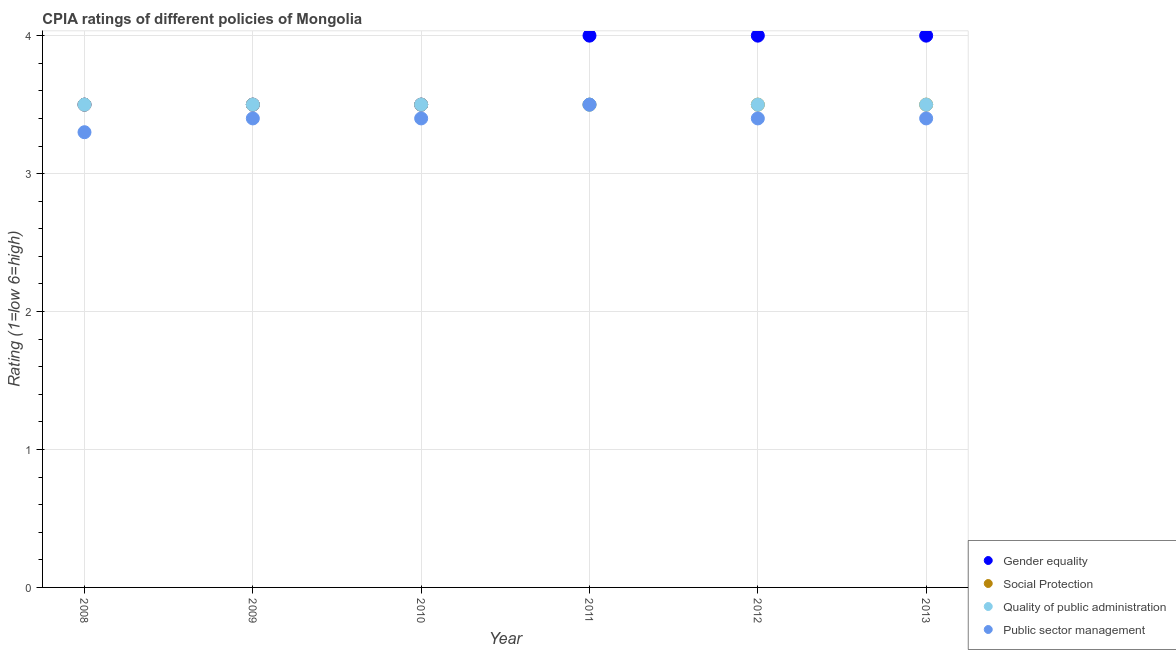How many different coloured dotlines are there?
Your answer should be very brief. 4. Is the number of dotlines equal to the number of legend labels?
Provide a short and direct response. Yes. Across all years, what is the minimum cpia rating of public sector management?
Your response must be concise. 3.3. In which year was the cpia rating of gender equality minimum?
Your answer should be compact. 2008. What is the difference between the cpia rating of quality of public administration in 2012 and the cpia rating of social protection in 2009?
Your response must be concise. 0. What is the average cpia rating of gender equality per year?
Offer a terse response. 3.75. What is the ratio of the cpia rating of public sector management in 2009 to that in 2011?
Your answer should be very brief. 0.97. Is the cpia rating of public sector management in 2010 less than that in 2011?
Provide a succinct answer. Yes. What is the difference between the highest and the second highest cpia rating of public sector management?
Keep it short and to the point. 0.1. What is the difference between the highest and the lowest cpia rating of social protection?
Offer a very short reply. 0. In how many years, is the cpia rating of gender equality greater than the average cpia rating of gender equality taken over all years?
Offer a very short reply. 3. Is the sum of the cpia rating of public sector management in 2009 and 2013 greater than the maximum cpia rating of gender equality across all years?
Provide a short and direct response. Yes. Is it the case that in every year, the sum of the cpia rating of gender equality and cpia rating of social protection is greater than the sum of cpia rating of public sector management and cpia rating of quality of public administration?
Your response must be concise. No. How many years are there in the graph?
Ensure brevity in your answer.  6. What is the difference between two consecutive major ticks on the Y-axis?
Your response must be concise. 1. Does the graph contain any zero values?
Provide a succinct answer. No. Does the graph contain grids?
Offer a very short reply. Yes. Where does the legend appear in the graph?
Offer a terse response. Bottom right. How many legend labels are there?
Provide a short and direct response. 4. How are the legend labels stacked?
Your answer should be very brief. Vertical. What is the title of the graph?
Give a very brief answer. CPIA ratings of different policies of Mongolia. What is the label or title of the X-axis?
Make the answer very short. Year. What is the label or title of the Y-axis?
Offer a very short reply. Rating (1=low 6=high). What is the Rating (1=low 6=high) in Gender equality in 2008?
Provide a succinct answer. 3.5. What is the Rating (1=low 6=high) of Quality of public administration in 2008?
Provide a short and direct response. 3.5. What is the Rating (1=low 6=high) of Public sector management in 2008?
Your response must be concise. 3.3. What is the Rating (1=low 6=high) of Gender equality in 2009?
Keep it short and to the point. 3.5. What is the Rating (1=low 6=high) in Social Protection in 2009?
Your answer should be very brief. 3.5. What is the Rating (1=low 6=high) of Gender equality in 2010?
Your answer should be very brief. 3.5. What is the Rating (1=low 6=high) in Gender equality in 2011?
Ensure brevity in your answer.  4. What is the Rating (1=low 6=high) in Quality of public administration in 2011?
Make the answer very short. 3.5. What is the Rating (1=low 6=high) of Social Protection in 2012?
Make the answer very short. 3.5. What is the Rating (1=low 6=high) of Public sector management in 2012?
Give a very brief answer. 3.4. What is the Rating (1=low 6=high) in Gender equality in 2013?
Offer a terse response. 4. What is the Rating (1=low 6=high) in Public sector management in 2013?
Keep it short and to the point. 3.4. Across all years, what is the maximum Rating (1=low 6=high) in Gender equality?
Your answer should be very brief. 4. Across all years, what is the maximum Rating (1=low 6=high) of Social Protection?
Give a very brief answer. 3.5. Across all years, what is the minimum Rating (1=low 6=high) of Gender equality?
Offer a terse response. 3.5. Across all years, what is the minimum Rating (1=low 6=high) of Social Protection?
Ensure brevity in your answer.  3.5. What is the total Rating (1=low 6=high) of Gender equality in the graph?
Your answer should be very brief. 22.5. What is the total Rating (1=low 6=high) in Public sector management in the graph?
Your response must be concise. 20.4. What is the difference between the Rating (1=low 6=high) in Gender equality in 2008 and that in 2009?
Provide a short and direct response. 0. What is the difference between the Rating (1=low 6=high) in Social Protection in 2008 and that in 2009?
Your answer should be compact. 0. What is the difference between the Rating (1=low 6=high) in Public sector management in 2008 and that in 2009?
Keep it short and to the point. -0.1. What is the difference between the Rating (1=low 6=high) in Gender equality in 2008 and that in 2010?
Your answer should be very brief. 0. What is the difference between the Rating (1=low 6=high) in Social Protection in 2008 and that in 2010?
Offer a very short reply. 0. What is the difference between the Rating (1=low 6=high) in Public sector management in 2008 and that in 2010?
Keep it short and to the point. -0.1. What is the difference between the Rating (1=low 6=high) of Gender equality in 2008 and that in 2011?
Ensure brevity in your answer.  -0.5. What is the difference between the Rating (1=low 6=high) of Social Protection in 2008 and that in 2011?
Keep it short and to the point. 0. What is the difference between the Rating (1=low 6=high) of Quality of public administration in 2008 and that in 2011?
Your answer should be very brief. 0. What is the difference between the Rating (1=low 6=high) in Public sector management in 2008 and that in 2011?
Keep it short and to the point. -0.2. What is the difference between the Rating (1=low 6=high) of Gender equality in 2008 and that in 2012?
Keep it short and to the point. -0.5. What is the difference between the Rating (1=low 6=high) of Social Protection in 2008 and that in 2012?
Your answer should be very brief. 0. What is the difference between the Rating (1=low 6=high) of Quality of public administration in 2008 and that in 2012?
Provide a succinct answer. 0. What is the difference between the Rating (1=low 6=high) in Quality of public administration in 2008 and that in 2013?
Your answer should be very brief. 0. What is the difference between the Rating (1=low 6=high) in Public sector management in 2008 and that in 2013?
Give a very brief answer. -0.1. What is the difference between the Rating (1=low 6=high) in Public sector management in 2009 and that in 2010?
Offer a terse response. 0. What is the difference between the Rating (1=low 6=high) in Social Protection in 2009 and that in 2011?
Provide a short and direct response. 0. What is the difference between the Rating (1=low 6=high) in Gender equality in 2009 and that in 2012?
Make the answer very short. -0.5. What is the difference between the Rating (1=low 6=high) in Quality of public administration in 2009 and that in 2012?
Ensure brevity in your answer.  0. What is the difference between the Rating (1=low 6=high) of Public sector management in 2009 and that in 2012?
Your response must be concise. 0. What is the difference between the Rating (1=low 6=high) in Gender equality in 2009 and that in 2013?
Your answer should be very brief. -0.5. What is the difference between the Rating (1=low 6=high) in Quality of public administration in 2009 and that in 2013?
Offer a terse response. 0. What is the difference between the Rating (1=low 6=high) in Public sector management in 2009 and that in 2013?
Your answer should be compact. 0. What is the difference between the Rating (1=low 6=high) of Gender equality in 2010 and that in 2011?
Offer a terse response. -0.5. What is the difference between the Rating (1=low 6=high) of Social Protection in 2010 and that in 2011?
Ensure brevity in your answer.  0. What is the difference between the Rating (1=low 6=high) in Gender equality in 2010 and that in 2012?
Offer a terse response. -0.5. What is the difference between the Rating (1=low 6=high) of Public sector management in 2010 and that in 2012?
Offer a terse response. 0. What is the difference between the Rating (1=low 6=high) in Social Protection in 2010 and that in 2013?
Offer a terse response. 0. What is the difference between the Rating (1=low 6=high) of Quality of public administration in 2010 and that in 2013?
Your answer should be very brief. 0. What is the difference between the Rating (1=low 6=high) in Public sector management in 2010 and that in 2013?
Offer a very short reply. 0. What is the difference between the Rating (1=low 6=high) in Social Protection in 2011 and that in 2012?
Your answer should be very brief. 0. What is the difference between the Rating (1=low 6=high) of Quality of public administration in 2011 and that in 2012?
Provide a short and direct response. 0. What is the difference between the Rating (1=low 6=high) in Public sector management in 2011 and that in 2013?
Provide a succinct answer. 0.1. What is the difference between the Rating (1=low 6=high) of Social Protection in 2012 and that in 2013?
Provide a succinct answer. 0. What is the difference between the Rating (1=low 6=high) of Public sector management in 2012 and that in 2013?
Provide a succinct answer. 0. What is the difference between the Rating (1=low 6=high) of Gender equality in 2008 and the Rating (1=low 6=high) of Social Protection in 2009?
Your answer should be compact. 0. What is the difference between the Rating (1=low 6=high) of Gender equality in 2008 and the Rating (1=low 6=high) of Quality of public administration in 2009?
Keep it short and to the point. 0. What is the difference between the Rating (1=low 6=high) in Social Protection in 2008 and the Rating (1=low 6=high) in Quality of public administration in 2009?
Your response must be concise. 0. What is the difference between the Rating (1=low 6=high) in Social Protection in 2008 and the Rating (1=low 6=high) in Public sector management in 2009?
Your answer should be compact. 0.1. What is the difference between the Rating (1=low 6=high) of Gender equality in 2008 and the Rating (1=low 6=high) of Social Protection in 2010?
Your response must be concise. 0. What is the difference between the Rating (1=low 6=high) in Social Protection in 2008 and the Rating (1=low 6=high) in Quality of public administration in 2010?
Provide a short and direct response. 0. What is the difference between the Rating (1=low 6=high) of Gender equality in 2008 and the Rating (1=low 6=high) of Social Protection in 2011?
Offer a very short reply. 0. What is the difference between the Rating (1=low 6=high) in Social Protection in 2008 and the Rating (1=low 6=high) in Public sector management in 2011?
Offer a very short reply. 0. What is the difference between the Rating (1=low 6=high) of Quality of public administration in 2008 and the Rating (1=low 6=high) of Public sector management in 2011?
Your answer should be compact. 0. What is the difference between the Rating (1=low 6=high) in Gender equality in 2008 and the Rating (1=low 6=high) in Social Protection in 2012?
Offer a very short reply. 0. What is the difference between the Rating (1=low 6=high) in Gender equality in 2008 and the Rating (1=low 6=high) in Public sector management in 2012?
Your answer should be very brief. 0.1. What is the difference between the Rating (1=low 6=high) of Social Protection in 2008 and the Rating (1=low 6=high) of Quality of public administration in 2012?
Your response must be concise. 0. What is the difference between the Rating (1=low 6=high) of Social Protection in 2008 and the Rating (1=low 6=high) of Public sector management in 2012?
Keep it short and to the point. 0.1. What is the difference between the Rating (1=low 6=high) of Social Protection in 2008 and the Rating (1=low 6=high) of Public sector management in 2013?
Ensure brevity in your answer.  0.1. What is the difference between the Rating (1=low 6=high) of Quality of public administration in 2008 and the Rating (1=low 6=high) of Public sector management in 2013?
Your answer should be compact. 0.1. What is the difference between the Rating (1=low 6=high) of Gender equality in 2009 and the Rating (1=low 6=high) of Social Protection in 2010?
Ensure brevity in your answer.  0. What is the difference between the Rating (1=low 6=high) in Quality of public administration in 2009 and the Rating (1=low 6=high) in Public sector management in 2010?
Offer a very short reply. 0.1. What is the difference between the Rating (1=low 6=high) of Social Protection in 2009 and the Rating (1=low 6=high) of Quality of public administration in 2011?
Ensure brevity in your answer.  0. What is the difference between the Rating (1=low 6=high) in Social Protection in 2009 and the Rating (1=low 6=high) in Public sector management in 2011?
Make the answer very short. 0. What is the difference between the Rating (1=low 6=high) in Quality of public administration in 2009 and the Rating (1=low 6=high) in Public sector management in 2011?
Your answer should be very brief. 0. What is the difference between the Rating (1=low 6=high) of Gender equality in 2009 and the Rating (1=low 6=high) of Quality of public administration in 2013?
Your answer should be very brief. 0. What is the difference between the Rating (1=low 6=high) of Social Protection in 2009 and the Rating (1=low 6=high) of Quality of public administration in 2013?
Make the answer very short. 0. What is the difference between the Rating (1=low 6=high) in Quality of public administration in 2009 and the Rating (1=low 6=high) in Public sector management in 2013?
Keep it short and to the point. 0.1. What is the difference between the Rating (1=low 6=high) of Quality of public administration in 2010 and the Rating (1=low 6=high) of Public sector management in 2011?
Provide a short and direct response. 0. What is the difference between the Rating (1=low 6=high) in Gender equality in 2010 and the Rating (1=low 6=high) in Quality of public administration in 2012?
Make the answer very short. 0. What is the difference between the Rating (1=low 6=high) of Quality of public administration in 2010 and the Rating (1=low 6=high) of Public sector management in 2012?
Make the answer very short. 0.1. What is the difference between the Rating (1=low 6=high) in Gender equality in 2010 and the Rating (1=low 6=high) in Social Protection in 2013?
Offer a very short reply. 0. What is the difference between the Rating (1=low 6=high) in Gender equality in 2010 and the Rating (1=low 6=high) in Quality of public administration in 2013?
Your answer should be compact. 0. What is the difference between the Rating (1=low 6=high) of Social Protection in 2010 and the Rating (1=low 6=high) of Quality of public administration in 2013?
Offer a very short reply. 0. What is the difference between the Rating (1=low 6=high) in Social Protection in 2010 and the Rating (1=low 6=high) in Public sector management in 2013?
Make the answer very short. 0.1. What is the difference between the Rating (1=low 6=high) of Quality of public administration in 2010 and the Rating (1=low 6=high) of Public sector management in 2013?
Make the answer very short. 0.1. What is the difference between the Rating (1=low 6=high) in Gender equality in 2011 and the Rating (1=low 6=high) in Quality of public administration in 2012?
Offer a terse response. 0.5. What is the difference between the Rating (1=low 6=high) in Gender equality in 2011 and the Rating (1=low 6=high) in Public sector management in 2012?
Offer a terse response. 0.6. What is the difference between the Rating (1=low 6=high) in Social Protection in 2011 and the Rating (1=low 6=high) in Public sector management in 2012?
Make the answer very short. 0.1. What is the difference between the Rating (1=low 6=high) of Quality of public administration in 2011 and the Rating (1=low 6=high) of Public sector management in 2012?
Keep it short and to the point. 0.1. What is the difference between the Rating (1=low 6=high) in Gender equality in 2011 and the Rating (1=low 6=high) in Public sector management in 2013?
Provide a short and direct response. 0.6. What is the difference between the Rating (1=low 6=high) in Social Protection in 2011 and the Rating (1=low 6=high) in Public sector management in 2013?
Keep it short and to the point. 0.1. What is the difference between the Rating (1=low 6=high) of Quality of public administration in 2011 and the Rating (1=low 6=high) of Public sector management in 2013?
Your response must be concise. 0.1. What is the difference between the Rating (1=low 6=high) of Social Protection in 2012 and the Rating (1=low 6=high) of Quality of public administration in 2013?
Offer a terse response. 0. What is the difference between the Rating (1=low 6=high) of Quality of public administration in 2012 and the Rating (1=low 6=high) of Public sector management in 2013?
Ensure brevity in your answer.  0.1. What is the average Rating (1=low 6=high) of Gender equality per year?
Give a very brief answer. 3.75. What is the average Rating (1=low 6=high) of Social Protection per year?
Your response must be concise. 3.5. In the year 2008, what is the difference between the Rating (1=low 6=high) of Gender equality and Rating (1=low 6=high) of Public sector management?
Provide a succinct answer. 0.2. In the year 2008, what is the difference between the Rating (1=low 6=high) of Social Protection and Rating (1=low 6=high) of Quality of public administration?
Keep it short and to the point. 0. In the year 2008, what is the difference between the Rating (1=low 6=high) of Quality of public administration and Rating (1=low 6=high) of Public sector management?
Ensure brevity in your answer.  0.2. In the year 2009, what is the difference between the Rating (1=low 6=high) in Gender equality and Rating (1=low 6=high) in Social Protection?
Keep it short and to the point. 0. In the year 2009, what is the difference between the Rating (1=low 6=high) in Gender equality and Rating (1=low 6=high) in Public sector management?
Your answer should be very brief. 0.1. In the year 2009, what is the difference between the Rating (1=low 6=high) in Social Protection and Rating (1=low 6=high) in Quality of public administration?
Your response must be concise. 0. In the year 2009, what is the difference between the Rating (1=low 6=high) in Quality of public administration and Rating (1=low 6=high) in Public sector management?
Ensure brevity in your answer.  0.1. In the year 2010, what is the difference between the Rating (1=low 6=high) of Social Protection and Rating (1=low 6=high) of Quality of public administration?
Your response must be concise. 0. In the year 2011, what is the difference between the Rating (1=low 6=high) of Social Protection and Rating (1=low 6=high) of Public sector management?
Your answer should be very brief. 0. In the year 2011, what is the difference between the Rating (1=low 6=high) in Quality of public administration and Rating (1=low 6=high) in Public sector management?
Your response must be concise. 0. In the year 2012, what is the difference between the Rating (1=low 6=high) of Gender equality and Rating (1=low 6=high) of Public sector management?
Provide a short and direct response. 0.6. In the year 2012, what is the difference between the Rating (1=low 6=high) of Social Protection and Rating (1=low 6=high) of Quality of public administration?
Give a very brief answer. 0. In the year 2012, what is the difference between the Rating (1=low 6=high) in Social Protection and Rating (1=low 6=high) in Public sector management?
Provide a succinct answer. 0.1. In the year 2013, what is the difference between the Rating (1=low 6=high) of Gender equality and Rating (1=low 6=high) of Social Protection?
Offer a very short reply. 0.5. In the year 2013, what is the difference between the Rating (1=low 6=high) of Gender equality and Rating (1=low 6=high) of Quality of public administration?
Provide a short and direct response. 0.5. In the year 2013, what is the difference between the Rating (1=low 6=high) in Social Protection and Rating (1=low 6=high) in Quality of public administration?
Keep it short and to the point. 0. In the year 2013, what is the difference between the Rating (1=low 6=high) of Social Protection and Rating (1=low 6=high) of Public sector management?
Provide a short and direct response. 0.1. In the year 2013, what is the difference between the Rating (1=low 6=high) in Quality of public administration and Rating (1=low 6=high) in Public sector management?
Your response must be concise. 0.1. What is the ratio of the Rating (1=low 6=high) of Quality of public administration in 2008 to that in 2009?
Provide a short and direct response. 1. What is the ratio of the Rating (1=low 6=high) in Public sector management in 2008 to that in 2009?
Offer a very short reply. 0.97. What is the ratio of the Rating (1=low 6=high) in Public sector management in 2008 to that in 2010?
Provide a succinct answer. 0.97. What is the ratio of the Rating (1=low 6=high) of Social Protection in 2008 to that in 2011?
Make the answer very short. 1. What is the ratio of the Rating (1=low 6=high) in Public sector management in 2008 to that in 2011?
Keep it short and to the point. 0.94. What is the ratio of the Rating (1=low 6=high) of Social Protection in 2008 to that in 2012?
Your answer should be very brief. 1. What is the ratio of the Rating (1=low 6=high) in Quality of public administration in 2008 to that in 2012?
Give a very brief answer. 1. What is the ratio of the Rating (1=low 6=high) of Public sector management in 2008 to that in 2012?
Ensure brevity in your answer.  0.97. What is the ratio of the Rating (1=low 6=high) of Gender equality in 2008 to that in 2013?
Your response must be concise. 0.88. What is the ratio of the Rating (1=low 6=high) of Quality of public administration in 2008 to that in 2013?
Give a very brief answer. 1. What is the ratio of the Rating (1=low 6=high) in Public sector management in 2008 to that in 2013?
Your answer should be very brief. 0.97. What is the ratio of the Rating (1=low 6=high) of Social Protection in 2009 to that in 2010?
Make the answer very short. 1. What is the ratio of the Rating (1=low 6=high) in Quality of public administration in 2009 to that in 2010?
Your answer should be compact. 1. What is the ratio of the Rating (1=low 6=high) in Public sector management in 2009 to that in 2010?
Offer a very short reply. 1. What is the ratio of the Rating (1=low 6=high) in Public sector management in 2009 to that in 2011?
Your response must be concise. 0.97. What is the ratio of the Rating (1=low 6=high) of Gender equality in 2009 to that in 2012?
Provide a succinct answer. 0.88. What is the ratio of the Rating (1=low 6=high) of Social Protection in 2009 to that in 2012?
Give a very brief answer. 1. What is the ratio of the Rating (1=low 6=high) of Quality of public administration in 2009 to that in 2012?
Provide a succinct answer. 1. What is the ratio of the Rating (1=low 6=high) of Social Protection in 2009 to that in 2013?
Provide a short and direct response. 1. What is the ratio of the Rating (1=low 6=high) in Public sector management in 2009 to that in 2013?
Keep it short and to the point. 1. What is the ratio of the Rating (1=low 6=high) of Gender equality in 2010 to that in 2011?
Provide a succinct answer. 0.88. What is the ratio of the Rating (1=low 6=high) in Quality of public administration in 2010 to that in 2011?
Provide a succinct answer. 1. What is the ratio of the Rating (1=low 6=high) of Public sector management in 2010 to that in 2011?
Your answer should be very brief. 0.97. What is the ratio of the Rating (1=low 6=high) in Gender equality in 2010 to that in 2012?
Make the answer very short. 0.88. What is the ratio of the Rating (1=low 6=high) in Public sector management in 2010 to that in 2012?
Your response must be concise. 1. What is the ratio of the Rating (1=low 6=high) of Gender equality in 2010 to that in 2013?
Ensure brevity in your answer.  0.88. What is the ratio of the Rating (1=low 6=high) in Social Protection in 2010 to that in 2013?
Give a very brief answer. 1. What is the ratio of the Rating (1=low 6=high) in Quality of public administration in 2010 to that in 2013?
Give a very brief answer. 1. What is the ratio of the Rating (1=low 6=high) in Public sector management in 2010 to that in 2013?
Provide a short and direct response. 1. What is the ratio of the Rating (1=low 6=high) of Gender equality in 2011 to that in 2012?
Ensure brevity in your answer.  1. What is the ratio of the Rating (1=low 6=high) of Social Protection in 2011 to that in 2012?
Give a very brief answer. 1. What is the ratio of the Rating (1=low 6=high) of Public sector management in 2011 to that in 2012?
Provide a short and direct response. 1.03. What is the ratio of the Rating (1=low 6=high) in Social Protection in 2011 to that in 2013?
Give a very brief answer. 1. What is the ratio of the Rating (1=low 6=high) of Quality of public administration in 2011 to that in 2013?
Keep it short and to the point. 1. What is the ratio of the Rating (1=low 6=high) in Public sector management in 2011 to that in 2013?
Provide a short and direct response. 1.03. What is the ratio of the Rating (1=low 6=high) in Social Protection in 2012 to that in 2013?
Give a very brief answer. 1. What is the ratio of the Rating (1=low 6=high) in Quality of public administration in 2012 to that in 2013?
Make the answer very short. 1. What is the difference between the highest and the lowest Rating (1=low 6=high) of Quality of public administration?
Your answer should be very brief. 0. What is the difference between the highest and the lowest Rating (1=low 6=high) in Public sector management?
Offer a very short reply. 0.2. 